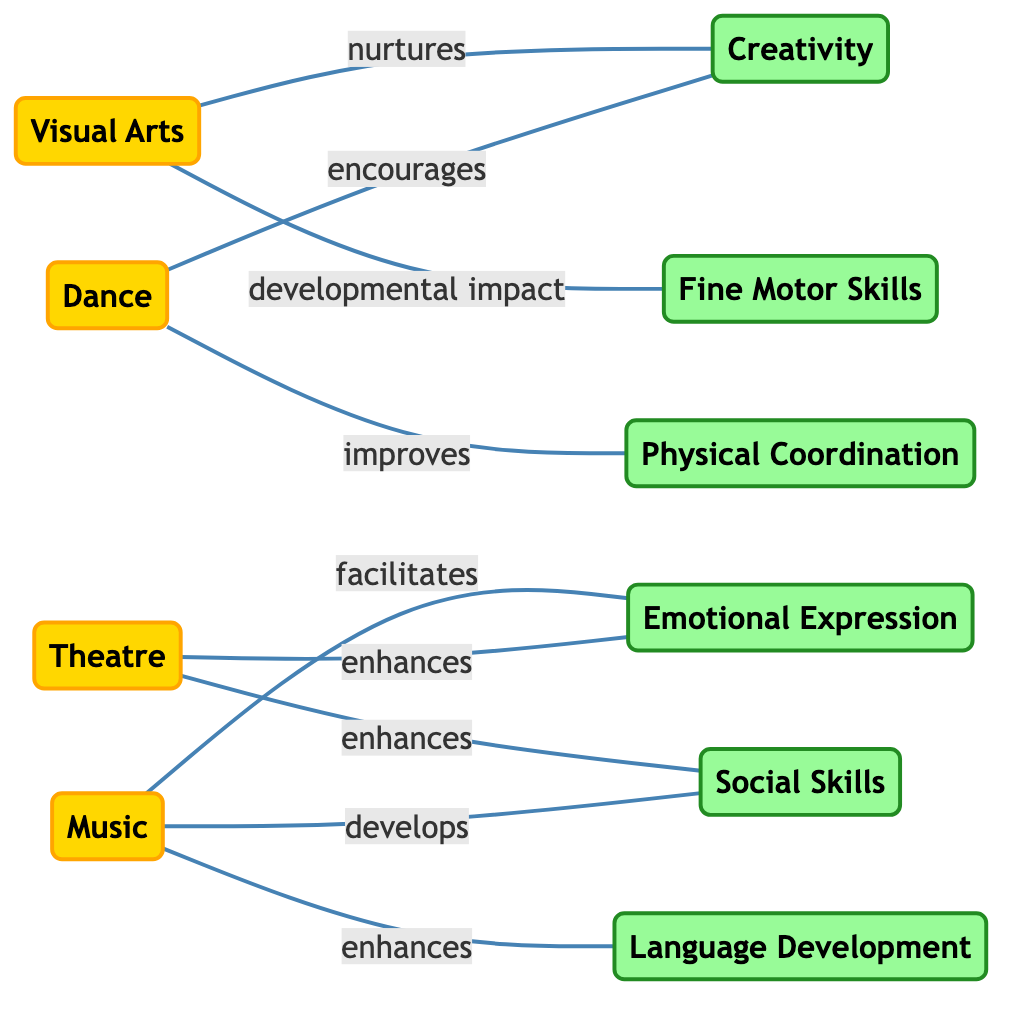What are the three art forms connected to Social Skills? The diagram shows edges connecting the Theatre and Music nodes to the Social Skills node. Therefore, the three art forms relating to Social Skills are Theatre and Music.
Answer: Theatre, Music What development skill is impacted by Visual Arts? The edge from Visual Arts to Fine Motor Skills indicates that Visual Arts has a developmental impact on Fine Motor Skills.
Answer: Fine Motor Skills How many edges are in the diagram? By counting the connections (edges) displayed in the diagram, there are 8 edges linking the nodes.
Answer: 8 Which art form enhances Emotional Expression? The edges from Music and Theatre both point to Emotional Expression, indicating that both enhance this skill. Therefore, the answer includes both nodes.
Answer: Music, Theatre Which art activity is linked to Physical Coordination? The diagram displays a direct link from the Dance node to the Physical Coordination node, showing that Dance improves Physical Coordination.
Answer: Dance How does Music relate to Language Development? The edge labeled "enhances" directly connects the Music node to the Language Development node, indicating a clear relationship.
Answer: enhances Which skill is nurtured by Visual Arts? The edge linking Visual Arts to Creativity denotes that Visual Arts nurtures this development skill.
Answer: Creativity Which two skills are connected to Dance? The diagram shows Dance linked to both Physical Coordination (improves) and Creativity (encourages), allowing us to identify both skills.
Answer: Physical Coordination, Creativity What is the total number of nodes in the diagram? By counting the individual art forms and skills listed, there are 10 distinct nodes in total.
Answer: 10 